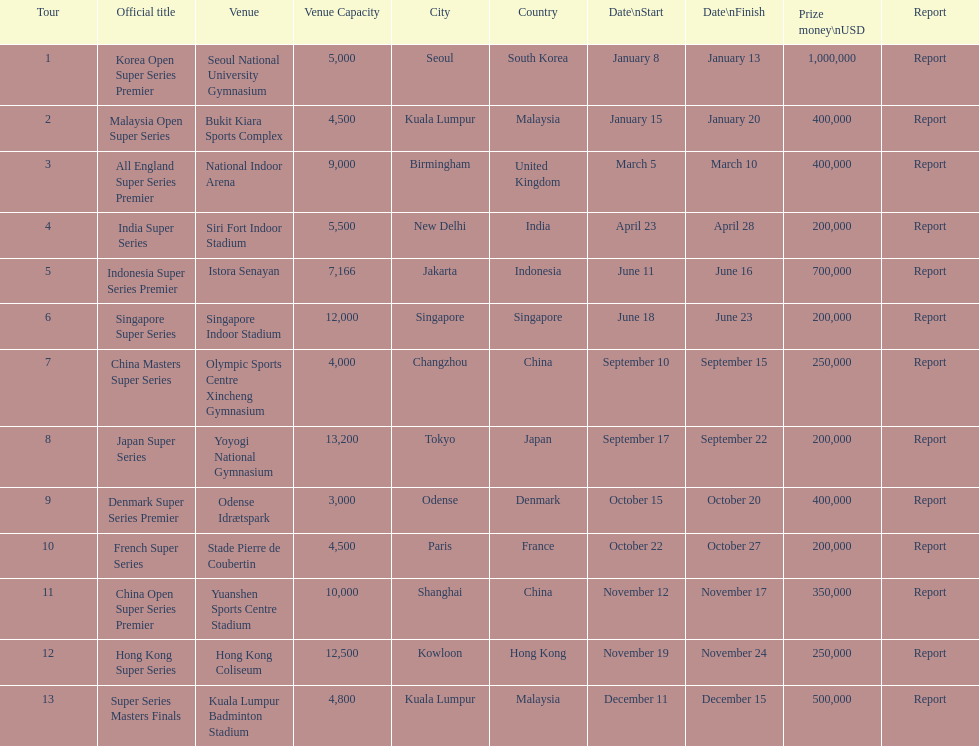What is the total prize payout for all 13 series? 5050000. 